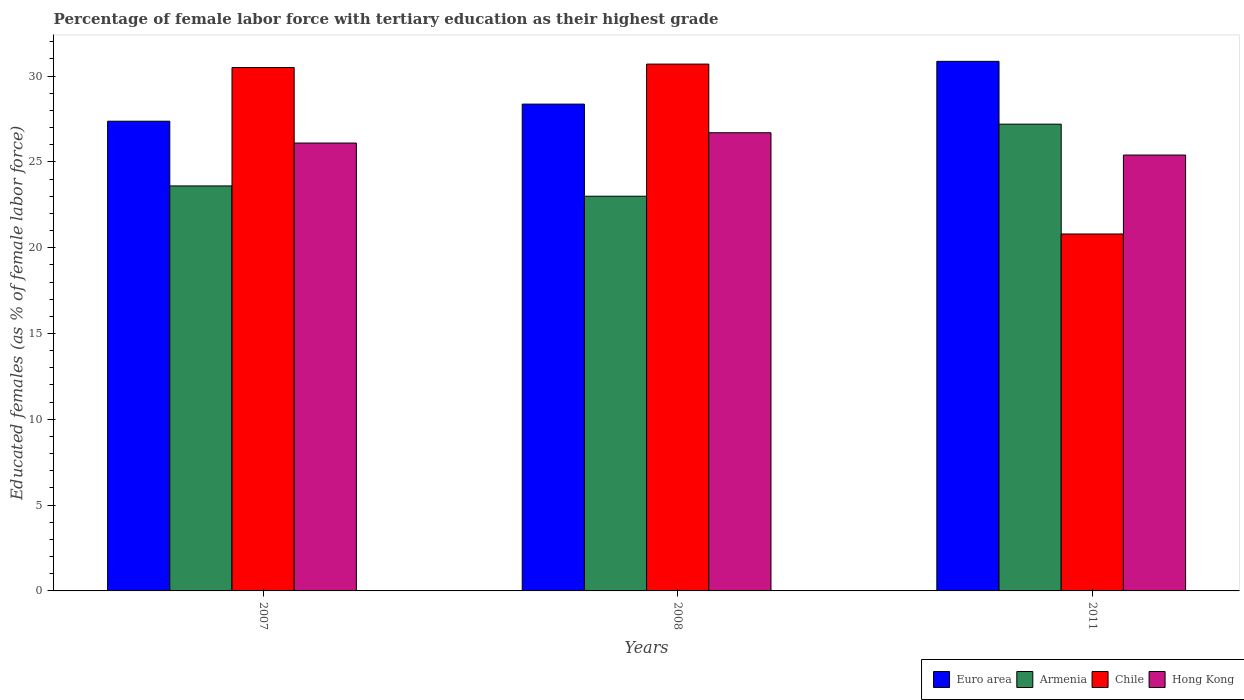How many groups of bars are there?
Ensure brevity in your answer.  3. Are the number of bars per tick equal to the number of legend labels?
Your response must be concise. Yes. Are the number of bars on each tick of the X-axis equal?
Your answer should be compact. Yes. What is the label of the 3rd group of bars from the left?
Make the answer very short. 2011. In how many cases, is the number of bars for a given year not equal to the number of legend labels?
Your answer should be very brief. 0. What is the percentage of female labor force with tertiary education in Chile in 2007?
Your answer should be compact. 30.5. Across all years, what is the maximum percentage of female labor force with tertiary education in Armenia?
Offer a very short reply. 27.2. Across all years, what is the minimum percentage of female labor force with tertiary education in Armenia?
Ensure brevity in your answer.  23. In which year was the percentage of female labor force with tertiary education in Hong Kong maximum?
Keep it short and to the point. 2008. In which year was the percentage of female labor force with tertiary education in Armenia minimum?
Ensure brevity in your answer.  2008. What is the total percentage of female labor force with tertiary education in Armenia in the graph?
Give a very brief answer. 73.8. What is the difference between the percentage of female labor force with tertiary education in Hong Kong in 2007 and that in 2011?
Offer a terse response. 0.7. What is the difference between the percentage of female labor force with tertiary education in Euro area in 2007 and the percentage of female labor force with tertiary education in Armenia in 2011?
Keep it short and to the point. 0.17. What is the average percentage of female labor force with tertiary education in Hong Kong per year?
Provide a succinct answer. 26.07. In the year 2011, what is the difference between the percentage of female labor force with tertiary education in Hong Kong and percentage of female labor force with tertiary education in Chile?
Provide a succinct answer. 4.6. What is the ratio of the percentage of female labor force with tertiary education in Hong Kong in 2007 to that in 2011?
Your response must be concise. 1.03. Is the difference between the percentage of female labor force with tertiary education in Hong Kong in 2008 and 2011 greater than the difference between the percentage of female labor force with tertiary education in Chile in 2008 and 2011?
Provide a succinct answer. No. What is the difference between the highest and the second highest percentage of female labor force with tertiary education in Armenia?
Ensure brevity in your answer.  3.6. What is the difference between the highest and the lowest percentage of female labor force with tertiary education in Chile?
Give a very brief answer. 9.9. In how many years, is the percentage of female labor force with tertiary education in Armenia greater than the average percentage of female labor force with tertiary education in Armenia taken over all years?
Your answer should be very brief. 1. Is it the case that in every year, the sum of the percentage of female labor force with tertiary education in Armenia and percentage of female labor force with tertiary education in Hong Kong is greater than the sum of percentage of female labor force with tertiary education in Chile and percentage of female labor force with tertiary education in Euro area?
Your answer should be very brief. No. What does the 2nd bar from the left in 2007 represents?
Your answer should be very brief. Armenia. Is it the case that in every year, the sum of the percentage of female labor force with tertiary education in Chile and percentage of female labor force with tertiary education in Hong Kong is greater than the percentage of female labor force with tertiary education in Euro area?
Your answer should be compact. Yes. Are all the bars in the graph horizontal?
Provide a succinct answer. No. What is the difference between two consecutive major ticks on the Y-axis?
Provide a succinct answer. 5. Does the graph contain any zero values?
Your answer should be very brief. No. Does the graph contain grids?
Make the answer very short. No. Where does the legend appear in the graph?
Your answer should be compact. Bottom right. How many legend labels are there?
Your answer should be compact. 4. What is the title of the graph?
Offer a very short reply. Percentage of female labor force with tertiary education as their highest grade. Does "Indonesia" appear as one of the legend labels in the graph?
Give a very brief answer. No. What is the label or title of the Y-axis?
Offer a very short reply. Educated females (as % of female labor force). What is the Educated females (as % of female labor force) in Euro area in 2007?
Provide a succinct answer. 27.37. What is the Educated females (as % of female labor force) in Armenia in 2007?
Your answer should be very brief. 23.6. What is the Educated females (as % of female labor force) of Chile in 2007?
Your response must be concise. 30.5. What is the Educated females (as % of female labor force) in Hong Kong in 2007?
Your answer should be compact. 26.1. What is the Educated females (as % of female labor force) of Euro area in 2008?
Keep it short and to the point. 28.37. What is the Educated females (as % of female labor force) in Chile in 2008?
Make the answer very short. 30.7. What is the Educated females (as % of female labor force) of Hong Kong in 2008?
Your answer should be compact. 26.7. What is the Educated females (as % of female labor force) of Euro area in 2011?
Your answer should be compact. 30.86. What is the Educated females (as % of female labor force) in Armenia in 2011?
Make the answer very short. 27.2. What is the Educated females (as % of female labor force) in Chile in 2011?
Offer a very short reply. 20.8. What is the Educated females (as % of female labor force) of Hong Kong in 2011?
Make the answer very short. 25.4. Across all years, what is the maximum Educated females (as % of female labor force) of Euro area?
Provide a short and direct response. 30.86. Across all years, what is the maximum Educated females (as % of female labor force) of Armenia?
Keep it short and to the point. 27.2. Across all years, what is the maximum Educated females (as % of female labor force) in Chile?
Provide a short and direct response. 30.7. Across all years, what is the maximum Educated females (as % of female labor force) in Hong Kong?
Offer a terse response. 26.7. Across all years, what is the minimum Educated females (as % of female labor force) of Euro area?
Ensure brevity in your answer.  27.37. Across all years, what is the minimum Educated females (as % of female labor force) of Armenia?
Give a very brief answer. 23. Across all years, what is the minimum Educated females (as % of female labor force) of Chile?
Keep it short and to the point. 20.8. Across all years, what is the minimum Educated females (as % of female labor force) in Hong Kong?
Keep it short and to the point. 25.4. What is the total Educated females (as % of female labor force) in Euro area in the graph?
Give a very brief answer. 86.6. What is the total Educated females (as % of female labor force) in Armenia in the graph?
Offer a terse response. 73.8. What is the total Educated females (as % of female labor force) in Chile in the graph?
Ensure brevity in your answer.  82. What is the total Educated females (as % of female labor force) in Hong Kong in the graph?
Provide a succinct answer. 78.2. What is the difference between the Educated females (as % of female labor force) in Euro area in 2007 and that in 2008?
Give a very brief answer. -1. What is the difference between the Educated females (as % of female labor force) of Armenia in 2007 and that in 2008?
Give a very brief answer. 0.6. What is the difference between the Educated females (as % of female labor force) in Euro area in 2007 and that in 2011?
Offer a terse response. -3.49. What is the difference between the Educated females (as % of female labor force) of Armenia in 2007 and that in 2011?
Your answer should be compact. -3.6. What is the difference between the Educated females (as % of female labor force) in Hong Kong in 2007 and that in 2011?
Offer a very short reply. 0.7. What is the difference between the Educated females (as % of female labor force) in Euro area in 2008 and that in 2011?
Keep it short and to the point. -2.49. What is the difference between the Educated females (as % of female labor force) in Armenia in 2008 and that in 2011?
Ensure brevity in your answer.  -4.2. What is the difference between the Educated females (as % of female labor force) in Chile in 2008 and that in 2011?
Offer a terse response. 9.9. What is the difference between the Educated females (as % of female labor force) of Euro area in 2007 and the Educated females (as % of female labor force) of Armenia in 2008?
Offer a terse response. 4.37. What is the difference between the Educated females (as % of female labor force) in Euro area in 2007 and the Educated females (as % of female labor force) in Chile in 2008?
Ensure brevity in your answer.  -3.33. What is the difference between the Educated females (as % of female labor force) of Euro area in 2007 and the Educated females (as % of female labor force) of Hong Kong in 2008?
Your answer should be compact. 0.67. What is the difference between the Educated females (as % of female labor force) in Chile in 2007 and the Educated females (as % of female labor force) in Hong Kong in 2008?
Your answer should be very brief. 3.8. What is the difference between the Educated females (as % of female labor force) of Euro area in 2007 and the Educated females (as % of female labor force) of Armenia in 2011?
Provide a short and direct response. 0.17. What is the difference between the Educated females (as % of female labor force) in Euro area in 2007 and the Educated females (as % of female labor force) in Chile in 2011?
Provide a short and direct response. 6.57. What is the difference between the Educated females (as % of female labor force) in Euro area in 2007 and the Educated females (as % of female labor force) in Hong Kong in 2011?
Offer a very short reply. 1.97. What is the difference between the Educated females (as % of female labor force) of Armenia in 2007 and the Educated females (as % of female labor force) of Hong Kong in 2011?
Ensure brevity in your answer.  -1.8. What is the difference between the Educated females (as % of female labor force) in Euro area in 2008 and the Educated females (as % of female labor force) in Armenia in 2011?
Your response must be concise. 1.17. What is the difference between the Educated females (as % of female labor force) of Euro area in 2008 and the Educated females (as % of female labor force) of Chile in 2011?
Your answer should be very brief. 7.57. What is the difference between the Educated females (as % of female labor force) of Euro area in 2008 and the Educated females (as % of female labor force) of Hong Kong in 2011?
Your answer should be compact. 2.97. What is the difference between the Educated females (as % of female labor force) of Chile in 2008 and the Educated females (as % of female labor force) of Hong Kong in 2011?
Give a very brief answer. 5.3. What is the average Educated females (as % of female labor force) in Euro area per year?
Offer a terse response. 28.87. What is the average Educated females (as % of female labor force) of Armenia per year?
Provide a succinct answer. 24.6. What is the average Educated females (as % of female labor force) in Chile per year?
Provide a succinct answer. 27.33. What is the average Educated females (as % of female labor force) of Hong Kong per year?
Your answer should be compact. 26.07. In the year 2007, what is the difference between the Educated females (as % of female labor force) in Euro area and Educated females (as % of female labor force) in Armenia?
Your response must be concise. 3.77. In the year 2007, what is the difference between the Educated females (as % of female labor force) in Euro area and Educated females (as % of female labor force) in Chile?
Your answer should be compact. -3.13. In the year 2007, what is the difference between the Educated females (as % of female labor force) of Euro area and Educated females (as % of female labor force) of Hong Kong?
Give a very brief answer. 1.27. In the year 2007, what is the difference between the Educated females (as % of female labor force) of Armenia and Educated females (as % of female labor force) of Chile?
Make the answer very short. -6.9. In the year 2008, what is the difference between the Educated females (as % of female labor force) in Euro area and Educated females (as % of female labor force) in Armenia?
Your response must be concise. 5.37. In the year 2008, what is the difference between the Educated females (as % of female labor force) of Euro area and Educated females (as % of female labor force) of Chile?
Keep it short and to the point. -2.33. In the year 2008, what is the difference between the Educated females (as % of female labor force) of Euro area and Educated females (as % of female labor force) of Hong Kong?
Your answer should be compact. 1.67. In the year 2008, what is the difference between the Educated females (as % of female labor force) in Armenia and Educated females (as % of female labor force) in Chile?
Ensure brevity in your answer.  -7.7. In the year 2011, what is the difference between the Educated females (as % of female labor force) of Euro area and Educated females (as % of female labor force) of Armenia?
Ensure brevity in your answer.  3.66. In the year 2011, what is the difference between the Educated females (as % of female labor force) of Euro area and Educated females (as % of female labor force) of Chile?
Your answer should be very brief. 10.06. In the year 2011, what is the difference between the Educated females (as % of female labor force) in Euro area and Educated females (as % of female labor force) in Hong Kong?
Provide a short and direct response. 5.46. In the year 2011, what is the difference between the Educated females (as % of female labor force) in Armenia and Educated females (as % of female labor force) in Chile?
Your response must be concise. 6.4. In the year 2011, what is the difference between the Educated females (as % of female labor force) in Armenia and Educated females (as % of female labor force) in Hong Kong?
Make the answer very short. 1.8. What is the ratio of the Educated females (as % of female labor force) in Euro area in 2007 to that in 2008?
Ensure brevity in your answer.  0.96. What is the ratio of the Educated females (as % of female labor force) of Armenia in 2007 to that in 2008?
Make the answer very short. 1.03. What is the ratio of the Educated females (as % of female labor force) of Hong Kong in 2007 to that in 2008?
Your answer should be compact. 0.98. What is the ratio of the Educated females (as % of female labor force) of Euro area in 2007 to that in 2011?
Provide a succinct answer. 0.89. What is the ratio of the Educated females (as % of female labor force) of Armenia in 2007 to that in 2011?
Offer a terse response. 0.87. What is the ratio of the Educated females (as % of female labor force) in Chile in 2007 to that in 2011?
Make the answer very short. 1.47. What is the ratio of the Educated females (as % of female labor force) in Hong Kong in 2007 to that in 2011?
Your response must be concise. 1.03. What is the ratio of the Educated females (as % of female labor force) in Euro area in 2008 to that in 2011?
Provide a short and direct response. 0.92. What is the ratio of the Educated females (as % of female labor force) in Armenia in 2008 to that in 2011?
Keep it short and to the point. 0.85. What is the ratio of the Educated females (as % of female labor force) of Chile in 2008 to that in 2011?
Give a very brief answer. 1.48. What is the ratio of the Educated females (as % of female labor force) in Hong Kong in 2008 to that in 2011?
Make the answer very short. 1.05. What is the difference between the highest and the second highest Educated females (as % of female labor force) of Euro area?
Your answer should be very brief. 2.49. What is the difference between the highest and the lowest Educated females (as % of female labor force) in Euro area?
Give a very brief answer. 3.49. What is the difference between the highest and the lowest Educated females (as % of female labor force) of Armenia?
Provide a succinct answer. 4.2. What is the difference between the highest and the lowest Educated females (as % of female labor force) in Hong Kong?
Offer a terse response. 1.3. 